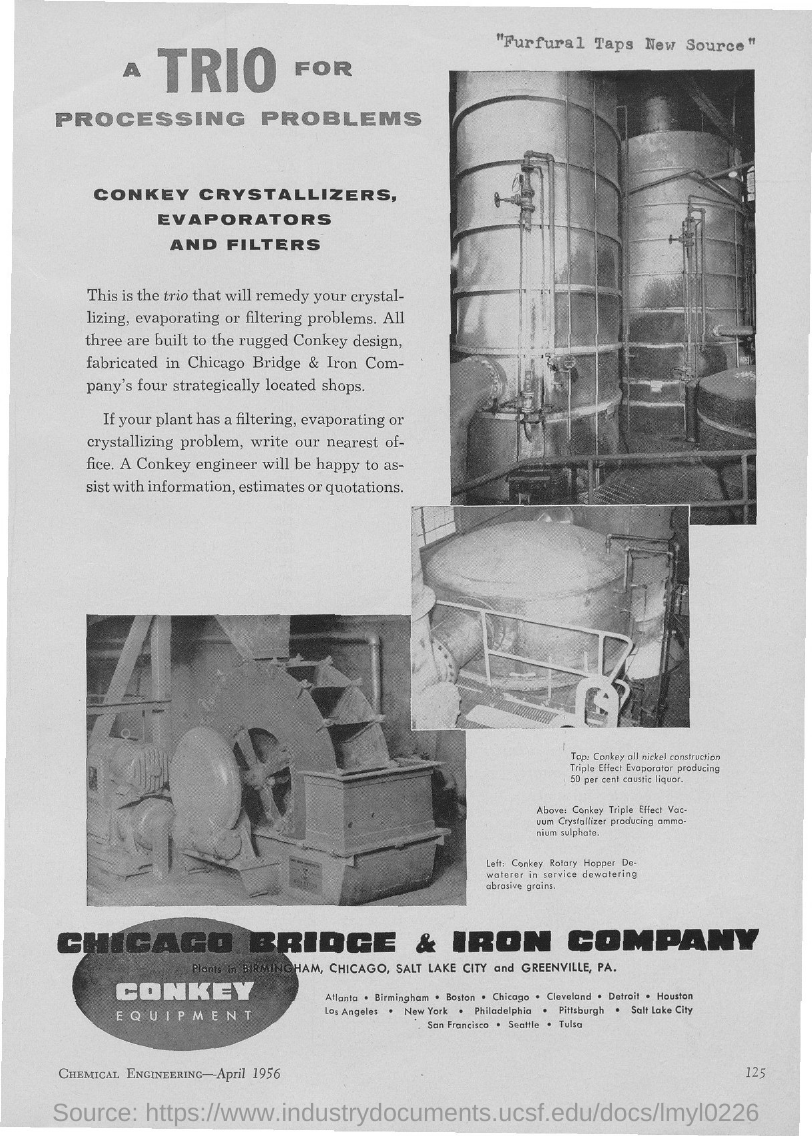All three are built to what design?
Your answer should be very brief. Rugged conkey design. What is the Date?
Offer a terse response. April 1956. What is the Page Number?
Ensure brevity in your answer.  125. 